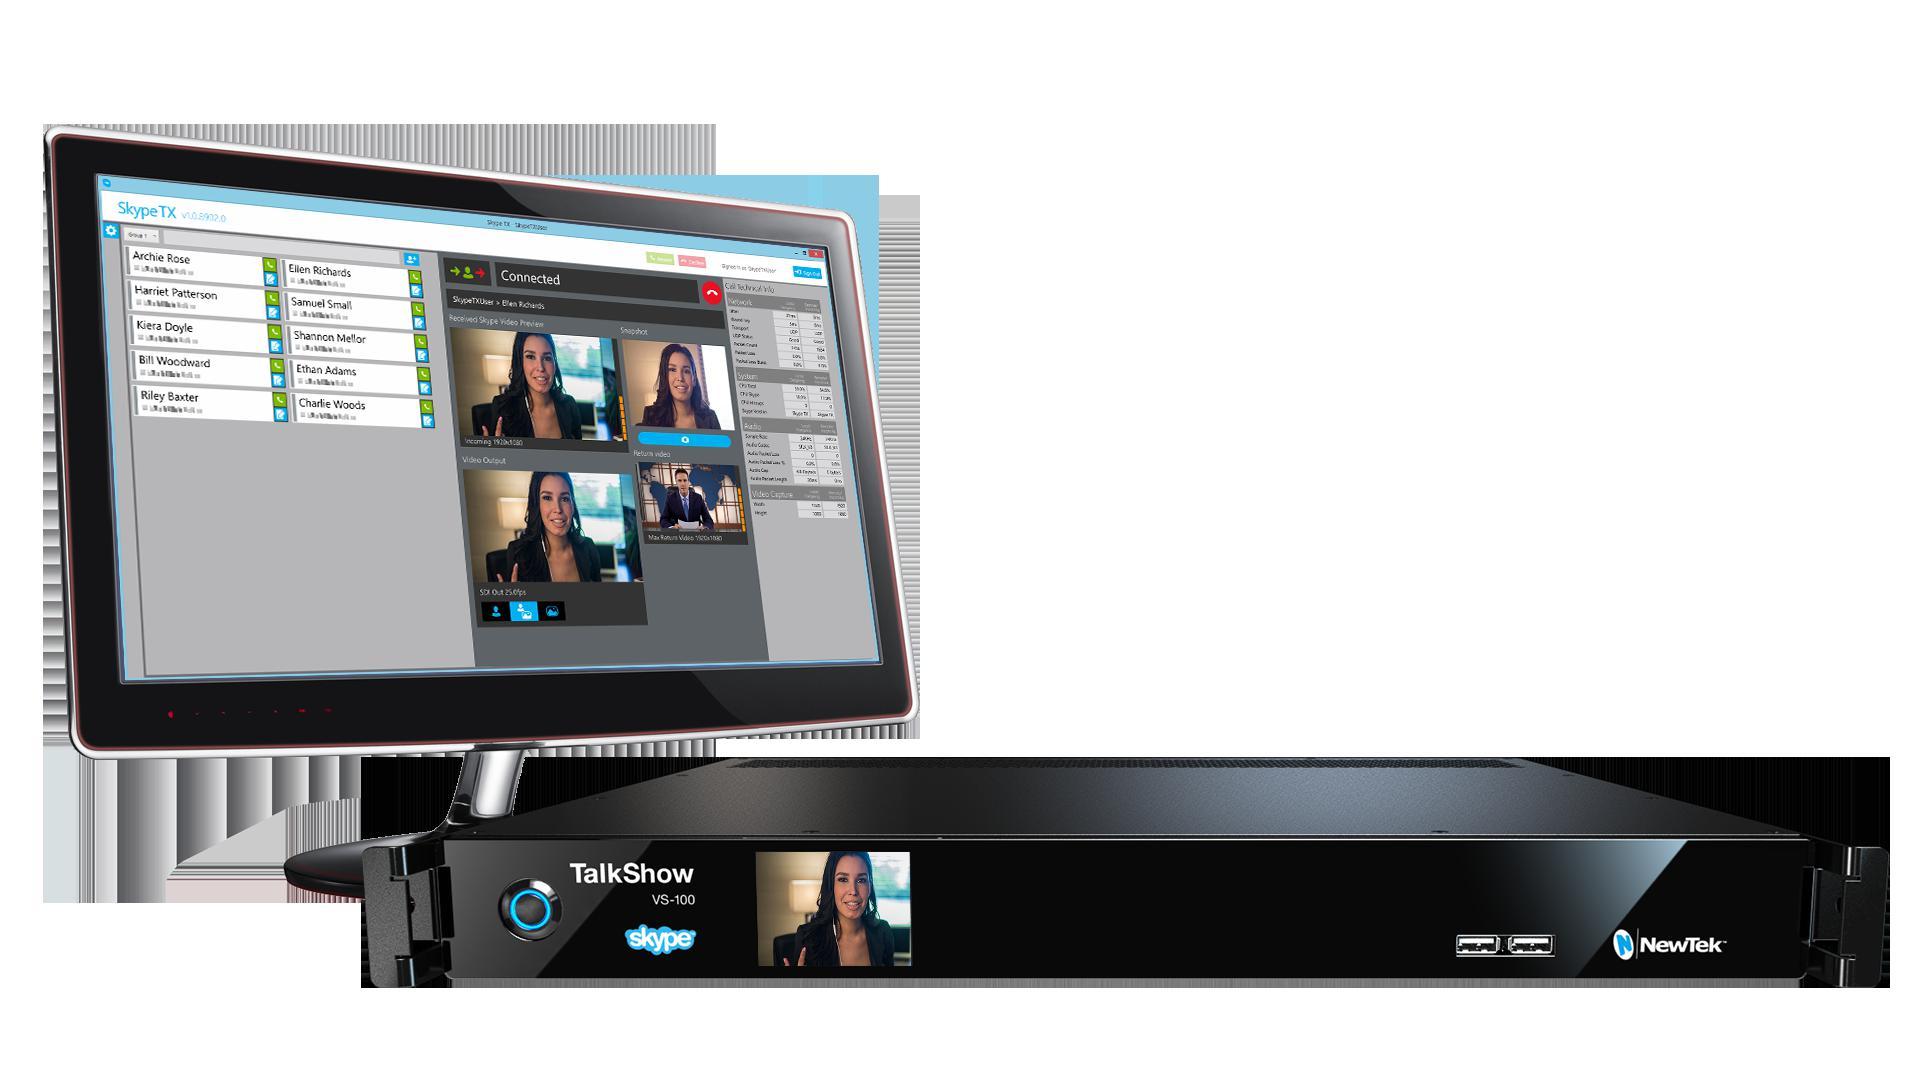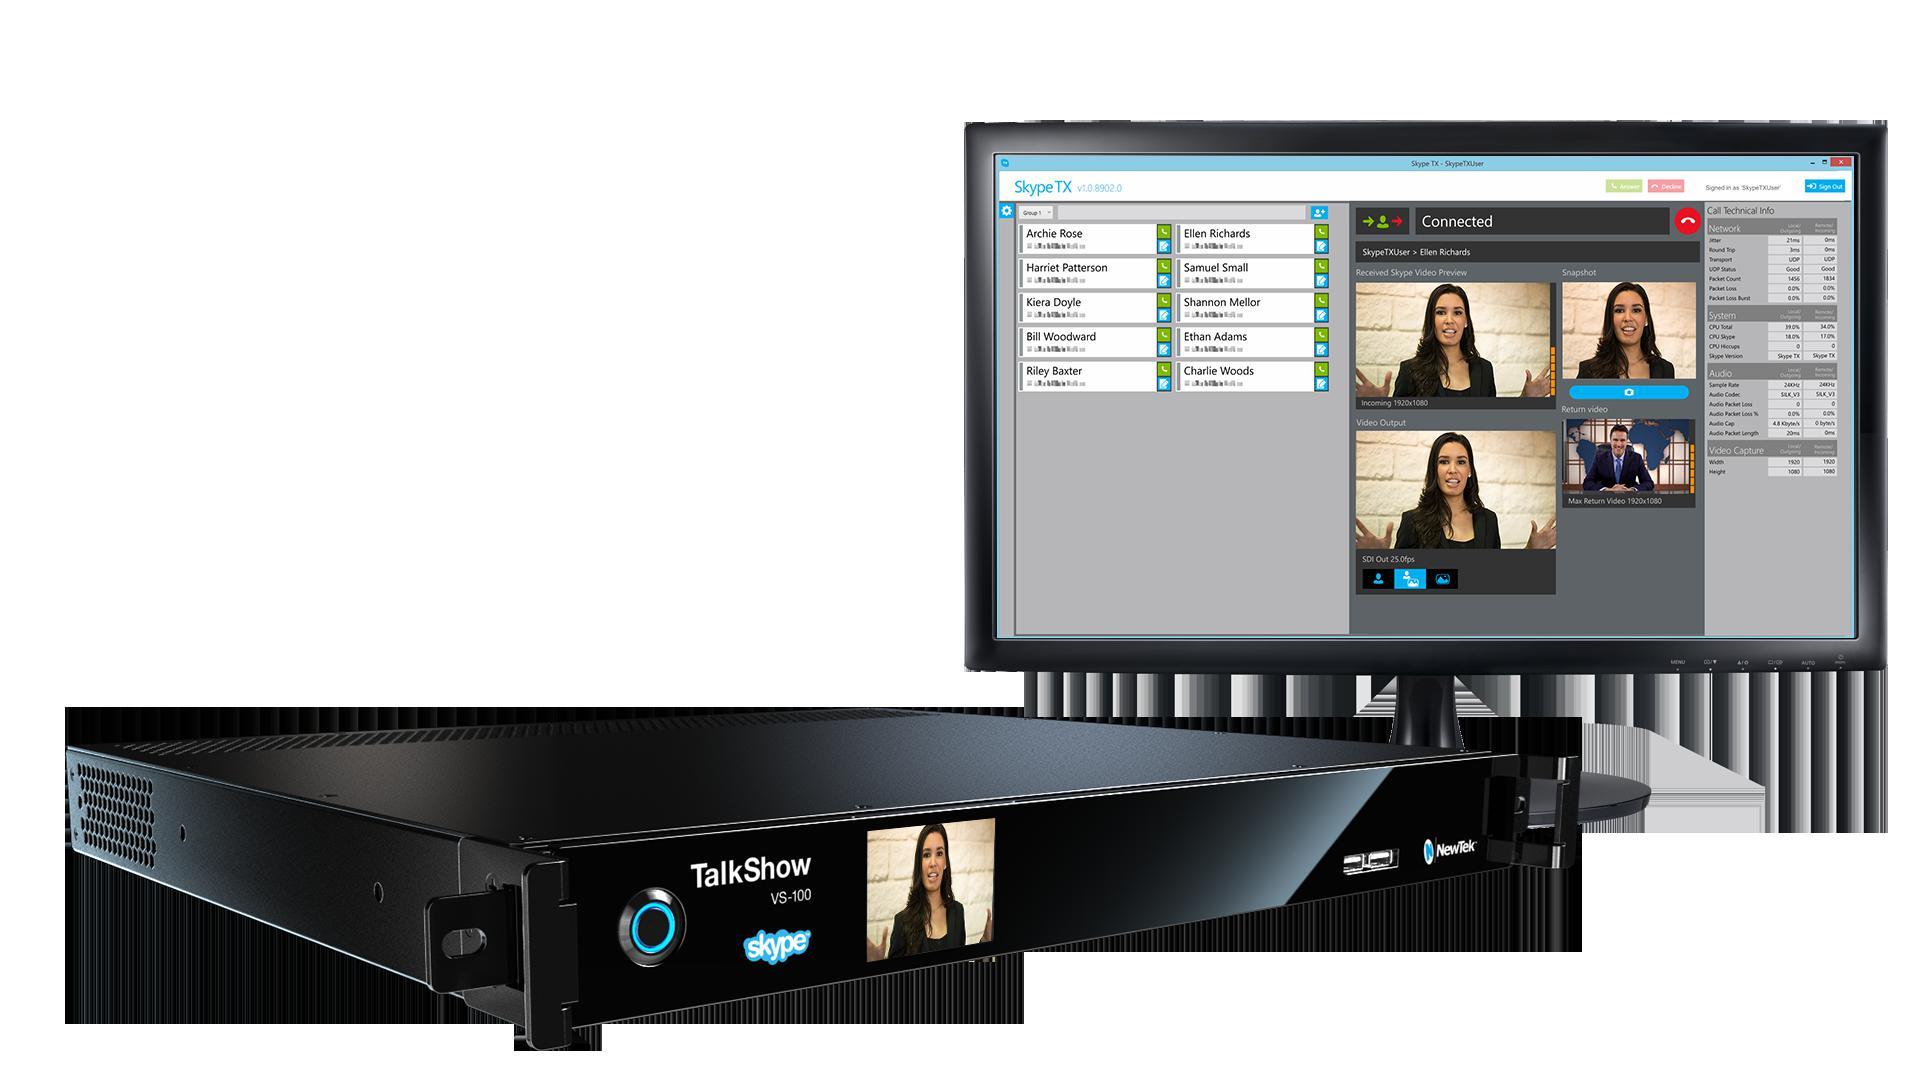The first image is the image on the left, the second image is the image on the right. Analyze the images presented: Is the assertion "One of the images contains a VCR." valid? Answer yes or no. No. 